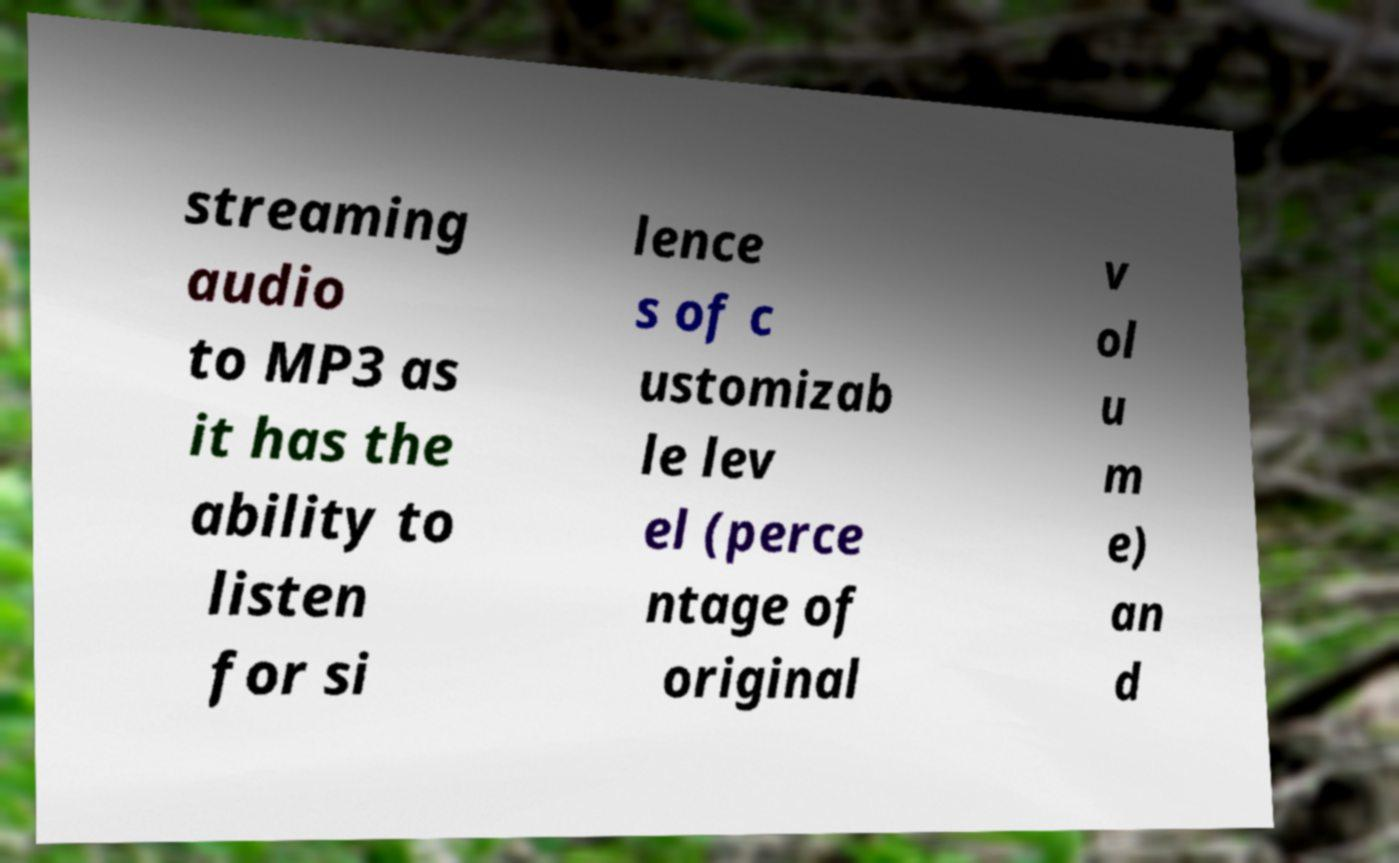Please identify and transcribe the text found in this image. streaming audio to MP3 as it has the ability to listen for si lence s of c ustomizab le lev el (perce ntage of original v ol u m e) an d 